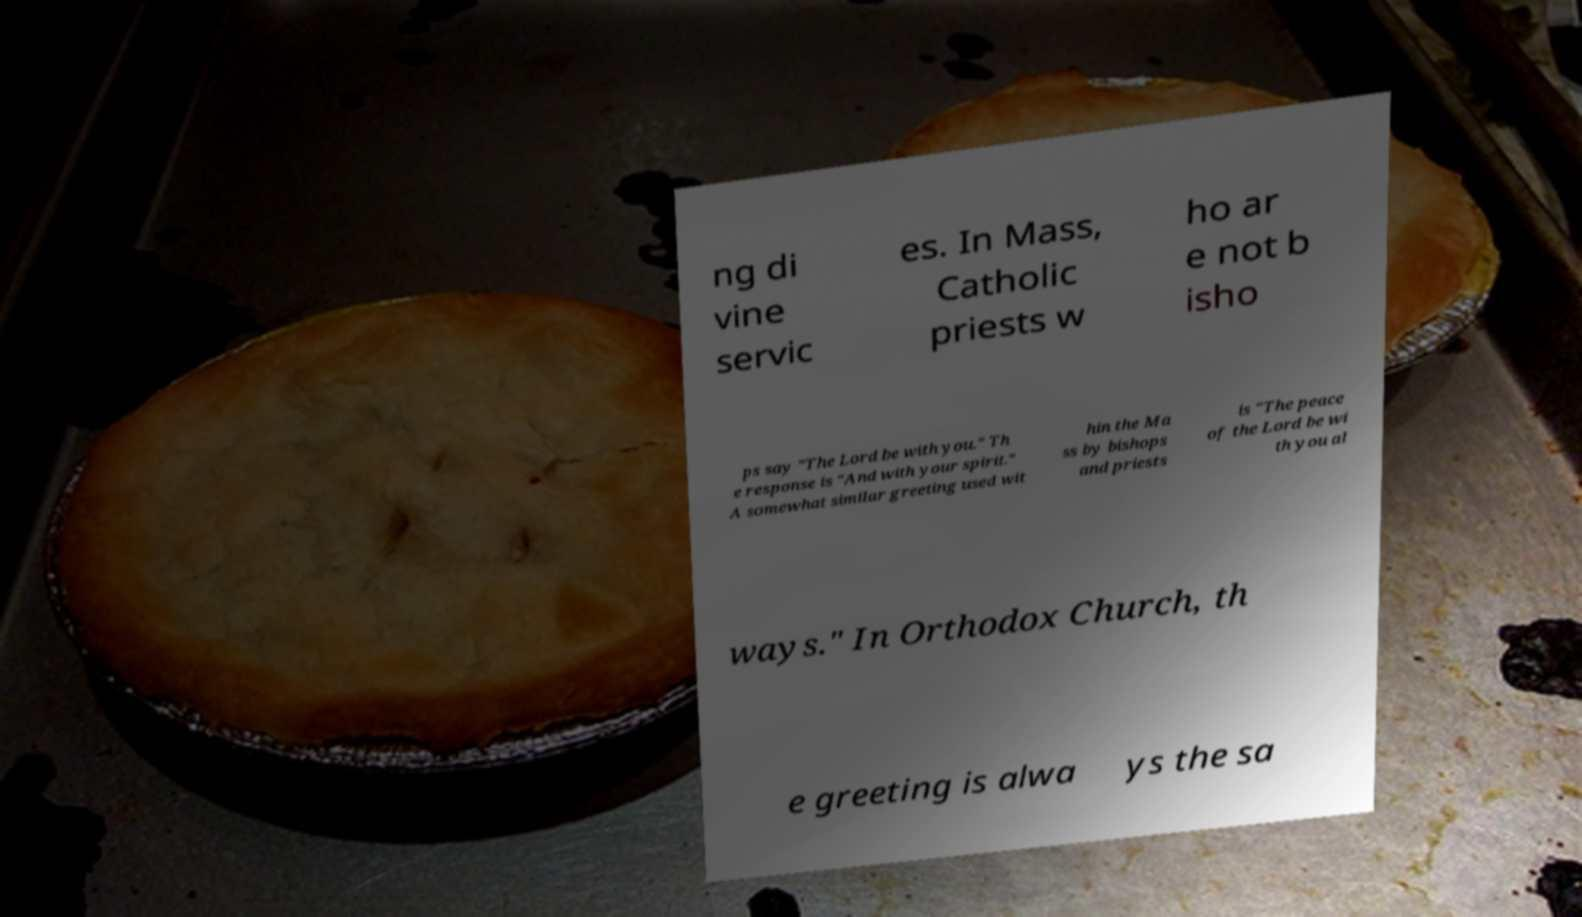Can you read and provide the text displayed in the image?This photo seems to have some interesting text. Can you extract and type it out for me? ng di vine servic es. In Mass, Catholic priests w ho ar e not b isho ps say "The Lord be with you." Th e response is "And with your spirit." A somewhat similar greeting used wit hin the Ma ss by bishops and priests is "The peace of the Lord be wi th you al ways." In Orthodox Church, th e greeting is alwa ys the sa 